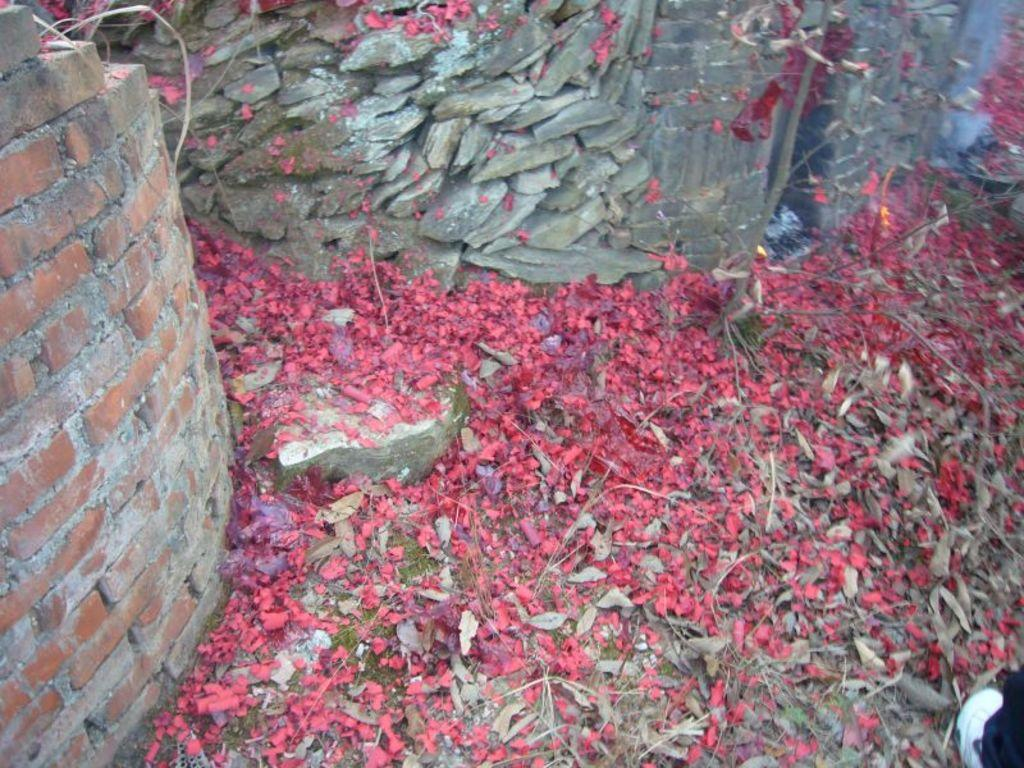What type of wall is on the left side of the image? There is a brick wall on the left side of the image. What can be found on the ground in the image? There are dried leaves and red color objects on the ground. What is visible in the background of the image? There is a stone wall and a tree in the background of the image. What type of flowers can be seen growing out of the tree's mouth in the image? There are no flowers or mouths present in the image; it features a brick wall, dried leaves, red color objects, a stone wall, and a tree in the background. 